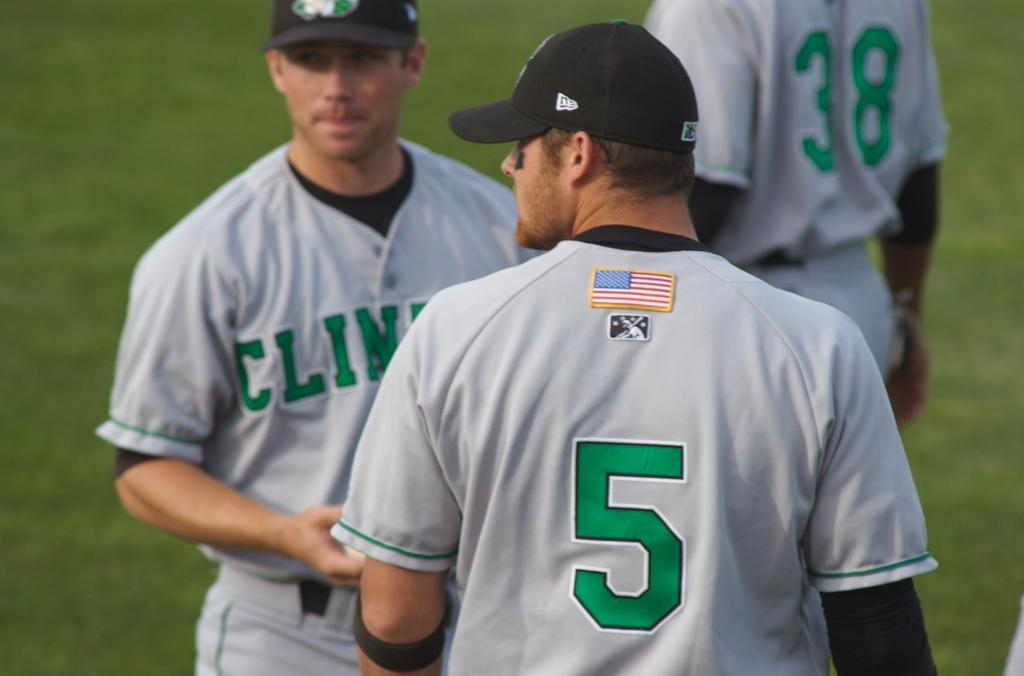Provide a one-sentence caption for the provided image. The player that wears number 5 is a player on a baseball team. 